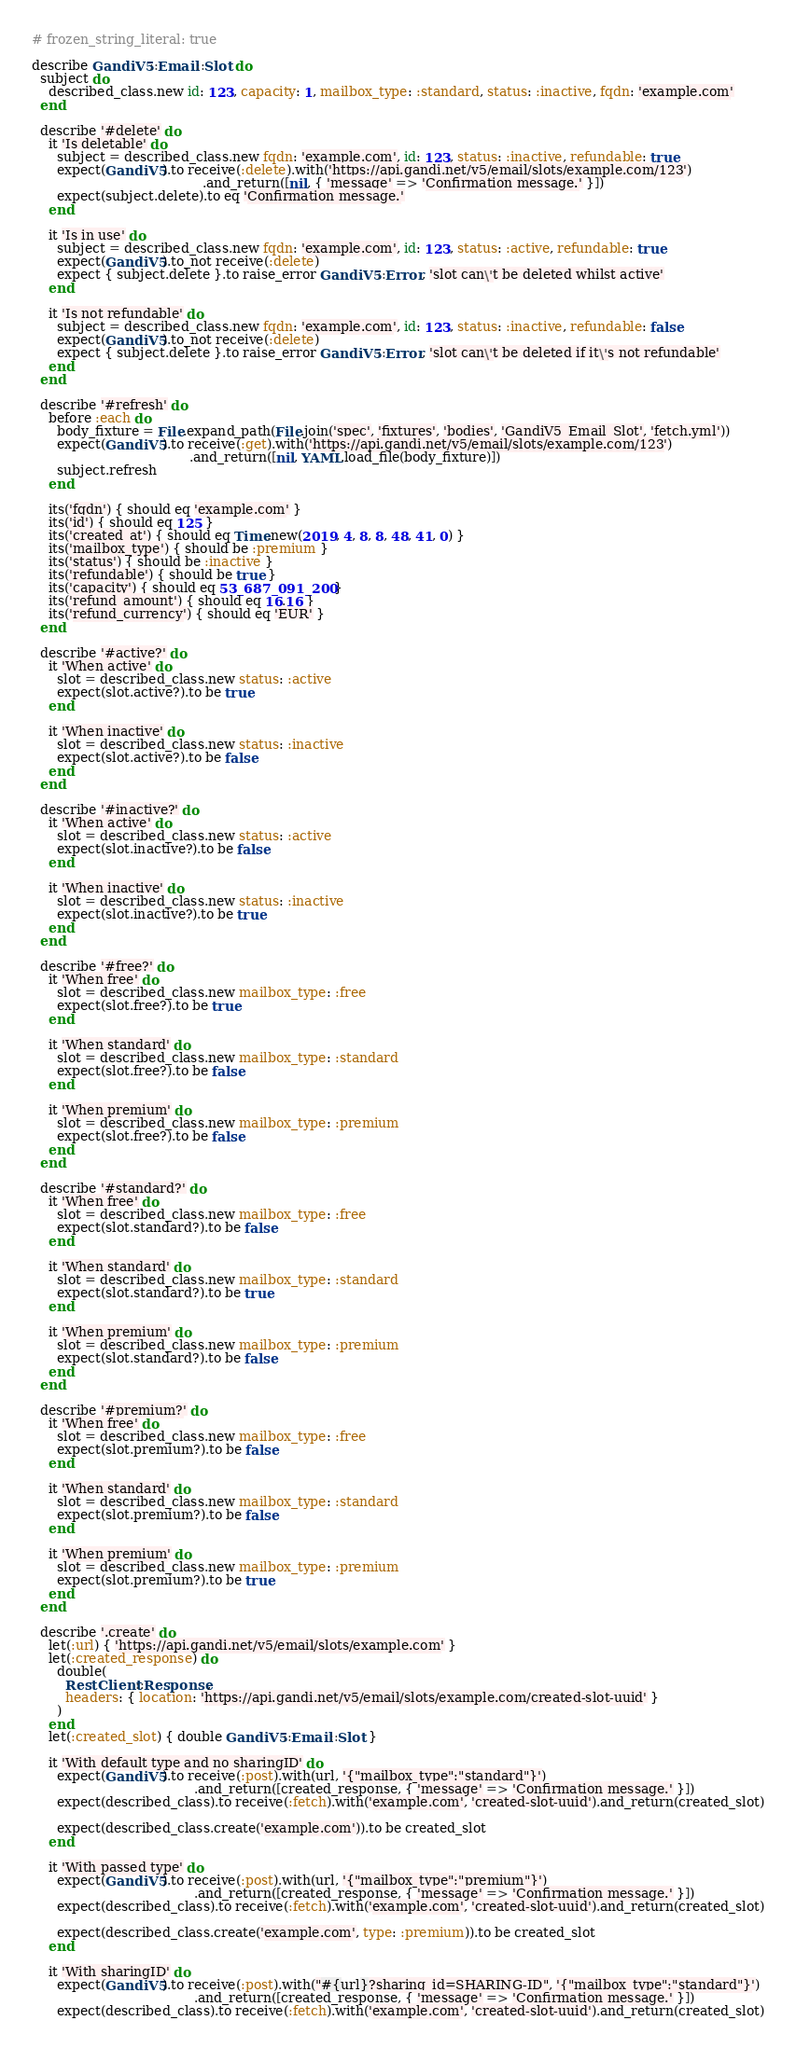Convert code to text. <code><loc_0><loc_0><loc_500><loc_500><_Ruby_># frozen_string_literal: true

describe GandiV5::Email::Slot do
  subject do
    described_class.new id: 123, capacity: 1, mailbox_type: :standard, status: :inactive, fqdn: 'example.com'
  end

  describe '#delete' do
    it 'Is deletable' do
      subject = described_class.new fqdn: 'example.com', id: 123, status: :inactive, refundable: true
      expect(GandiV5).to receive(:delete).with('https://api.gandi.net/v5/email/slots/example.com/123')
                                         .and_return([nil, { 'message' => 'Confirmation message.' }])
      expect(subject.delete).to eq 'Confirmation message.'
    end

    it 'Is in use' do
      subject = described_class.new fqdn: 'example.com', id: 123, status: :active, refundable: true
      expect(GandiV5).to_not receive(:delete)
      expect { subject.delete }.to raise_error GandiV5::Error, 'slot can\'t be deleted whilst active'
    end

    it 'Is not refundable' do
      subject = described_class.new fqdn: 'example.com', id: 123, status: :inactive, refundable: false
      expect(GandiV5).to_not receive(:delete)
      expect { subject.delete }.to raise_error GandiV5::Error, 'slot can\'t be deleted if it\'s not refundable'
    end
  end

  describe '#refresh' do
    before :each do
      body_fixture = File.expand_path(File.join('spec', 'fixtures', 'bodies', 'GandiV5_Email_Slot', 'fetch.yml'))
      expect(GandiV5).to receive(:get).with('https://api.gandi.net/v5/email/slots/example.com/123')
                                      .and_return([nil, YAML.load_file(body_fixture)])
      subject.refresh
    end

    its('fqdn') { should eq 'example.com' }
    its('id') { should eq 125 }
    its('created_at') { should eq Time.new(2019, 4, 8, 8, 48, 41, 0) }
    its('mailbox_type') { should be :premium }
    its('status') { should be :inactive }
    its('refundable') { should be true }
    its('capacity') { should eq 53_687_091_200 }
    its('refund_amount') { should eq 16.16 }
    its('refund_currency') { should eq 'EUR' }
  end

  describe '#active?' do
    it 'When active' do
      slot = described_class.new status: :active
      expect(slot.active?).to be true
    end

    it 'When inactive' do
      slot = described_class.new status: :inactive
      expect(slot.active?).to be false
    end
  end

  describe '#inactive?' do
    it 'When active' do
      slot = described_class.new status: :active
      expect(slot.inactive?).to be false
    end

    it 'When inactive' do
      slot = described_class.new status: :inactive
      expect(slot.inactive?).to be true
    end
  end

  describe '#free?' do
    it 'When free' do
      slot = described_class.new mailbox_type: :free
      expect(slot.free?).to be true
    end

    it 'When standard' do
      slot = described_class.new mailbox_type: :standard
      expect(slot.free?).to be false
    end

    it 'When premium' do
      slot = described_class.new mailbox_type: :premium
      expect(slot.free?).to be false
    end
  end

  describe '#standard?' do
    it 'When free' do
      slot = described_class.new mailbox_type: :free
      expect(slot.standard?).to be false
    end

    it 'When standard' do
      slot = described_class.new mailbox_type: :standard
      expect(slot.standard?).to be true
    end

    it 'When premium' do
      slot = described_class.new mailbox_type: :premium
      expect(slot.standard?).to be false
    end
  end

  describe '#premium?' do
    it 'When free' do
      slot = described_class.new mailbox_type: :free
      expect(slot.premium?).to be false
    end

    it 'When standard' do
      slot = described_class.new mailbox_type: :standard
      expect(slot.premium?).to be false
    end

    it 'When premium' do
      slot = described_class.new mailbox_type: :premium
      expect(slot.premium?).to be true
    end
  end

  describe '.create' do
    let(:url) { 'https://api.gandi.net/v5/email/slots/example.com' }
    let(:created_response) do
      double(
        RestClient::Response,
        headers: { location: 'https://api.gandi.net/v5/email/slots/example.com/created-slot-uuid' }
      )
    end
    let(:created_slot) { double GandiV5::Email::Slot }

    it 'With default type and no sharingID' do
      expect(GandiV5).to receive(:post).with(url, '{"mailbox_type":"standard"}')
                                       .and_return([created_response, { 'message' => 'Confirmation message.' }])
      expect(described_class).to receive(:fetch).with('example.com', 'created-slot-uuid').and_return(created_slot)

      expect(described_class.create('example.com')).to be created_slot
    end

    it 'With passed type' do
      expect(GandiV5).to receive(:post).with(url, '{"mailbox_type":"premium"}')
                                       .and_return([created_response, { 'message' => 'Confirmation message.' }])
      expect(described_class).to receive(:fetch).with('example.com', 'created-slot-uuid').and_return(created_slot)

      expect(described_class.create('example.com', type: :premium)).to be created_slot
    end

    it 'With sharingID' do
      expect(GandiV5).to receive(:post).with("#{url}?sharing_id=SHARING-ID", '{"mailbox_type":"standard"}')
                                       .and_return([created_response, { 'message' => 'Confirmation message.' }])
      expect(described_class).to receive(:fetch).with('example.com', 'created-slot-uuid').and_return(created_slot)
</code> 